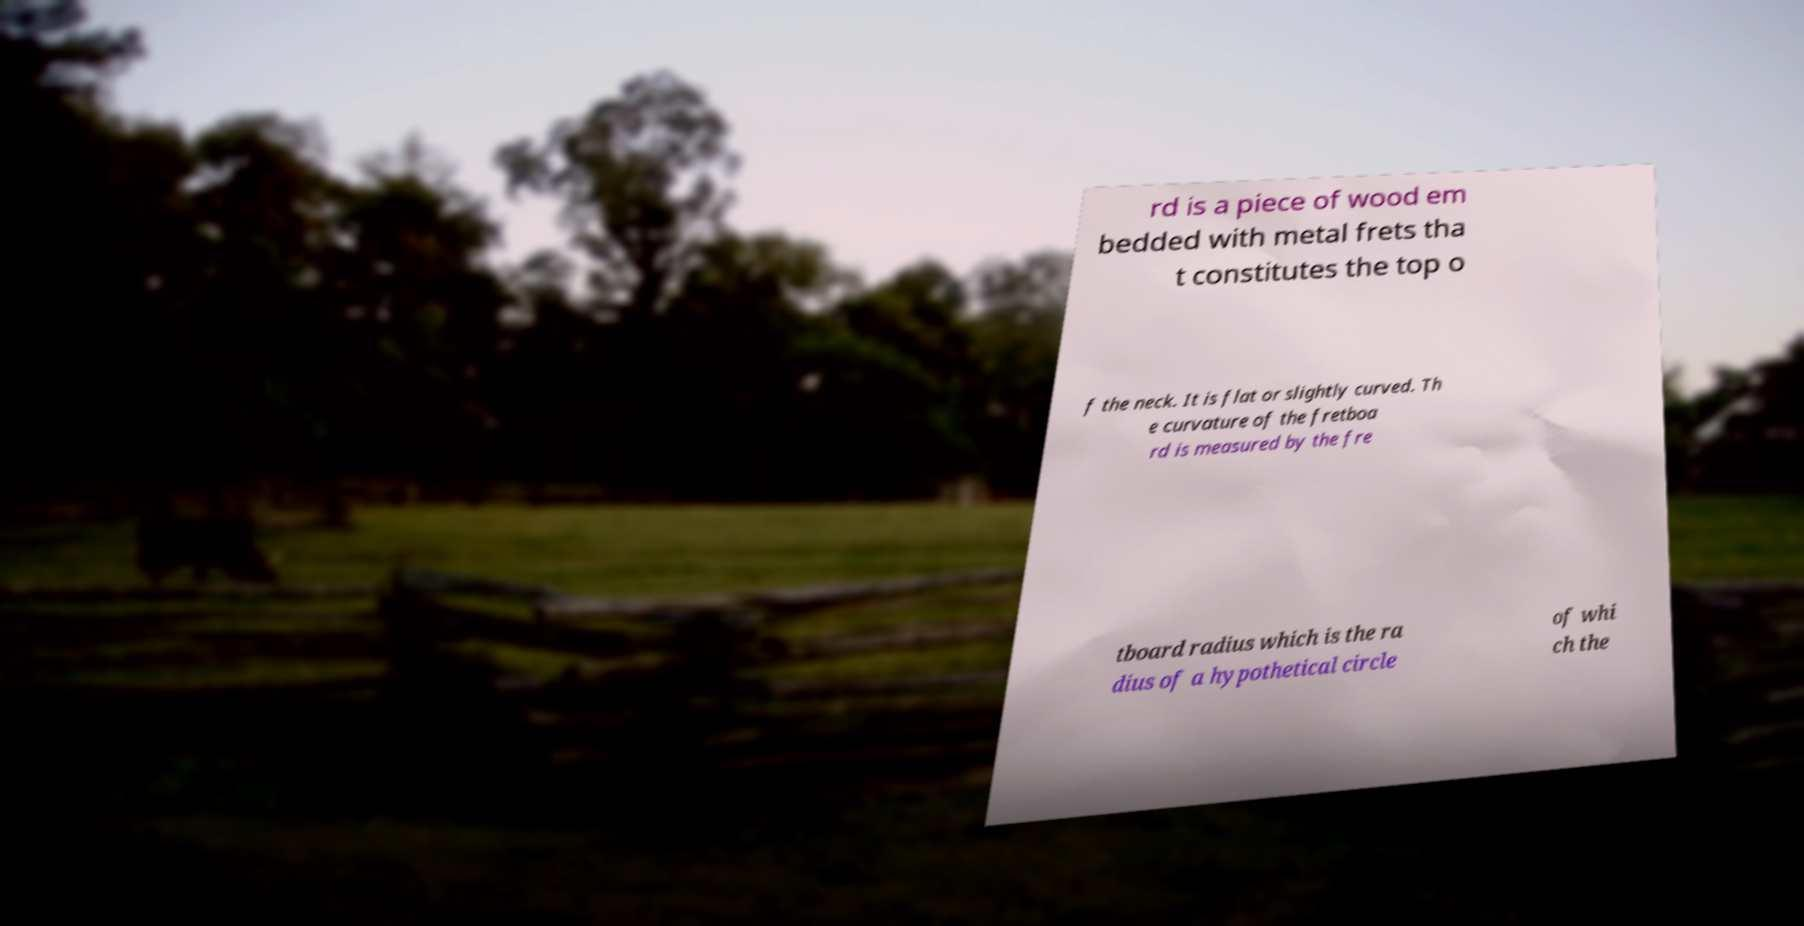Could you extract and type out the text from this image? rd is a piece of wood em bedded with metal frets tha t constitutes the top o f the neck. It is flat or slightly curved. Th e curvature of the fretboa rd is measured by the fre tboard radius which is the ra dius of a hypothetical circle of whi ch the 